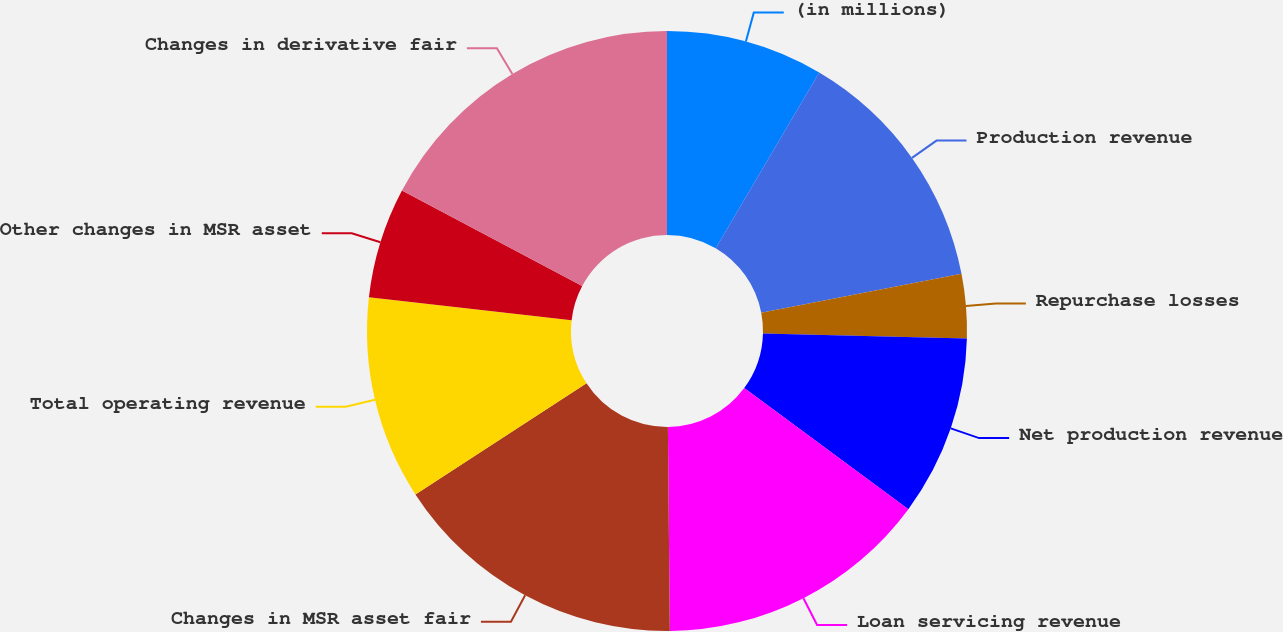Convert chart to OTSL. <chart><loc_0><loc_0><loc_500><loc_500><pie_chart><fcel>(in millions)<fcel>Production revenue<fcel>Repurchase losses<fcel>Net production revenue<fcel>Loan servicing revenue<fcel>Changes in MSR asset fair<fcel>Total operating revenue<fcel>Other changes in MSR asset<fcel>Changes in derivative fair<nl><fcel>8.47%<fcel>13.48%<fcel>3.45%<fcel>9.72%<fcel>14.73%<fcel>15.98%<fcel>10.97%<fcel>5.96%<fcel>17.24%<nl></chart> 